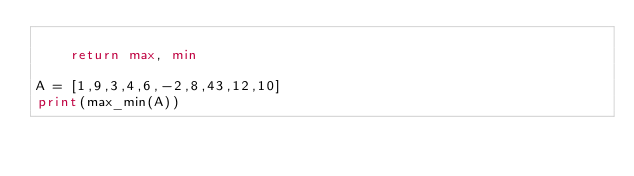Convert code to text. <code><loc_0><loc_0><loc_500><loc_500><_Python_>
    return max, min

A = [1,9,3,4,6,-2,8,43,12,10]
print(max_min(A))
</code> 